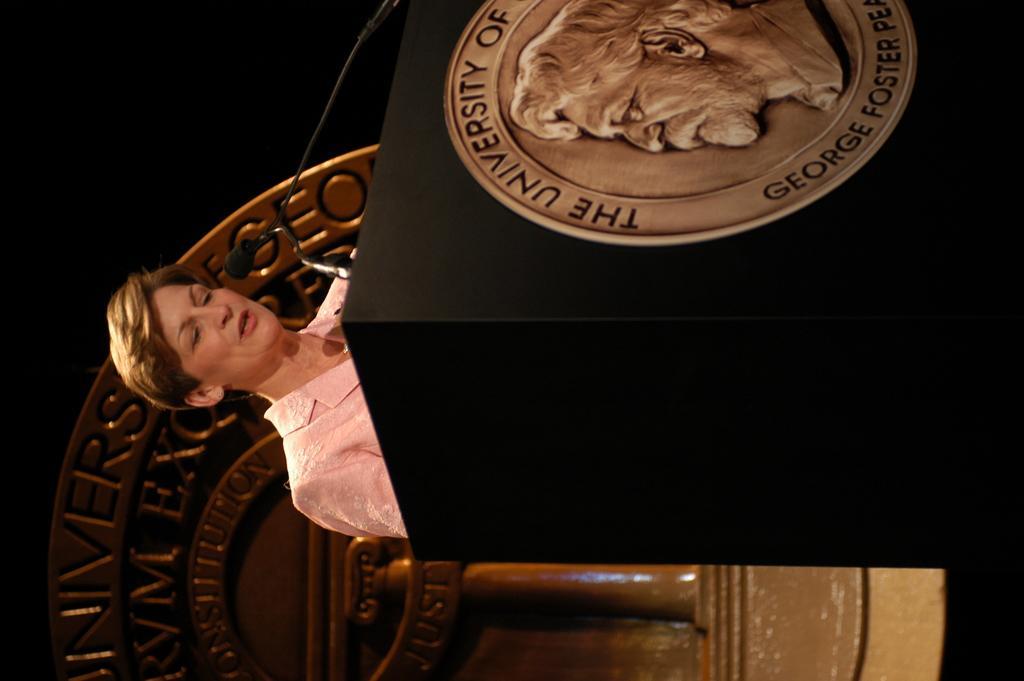Can you describe this image briefly? In this picture we can see a tilted image of a person standing behind a podium with a mike. We can see a golden emblem on the podium and on the wall behind the woman with some image and text on it. 